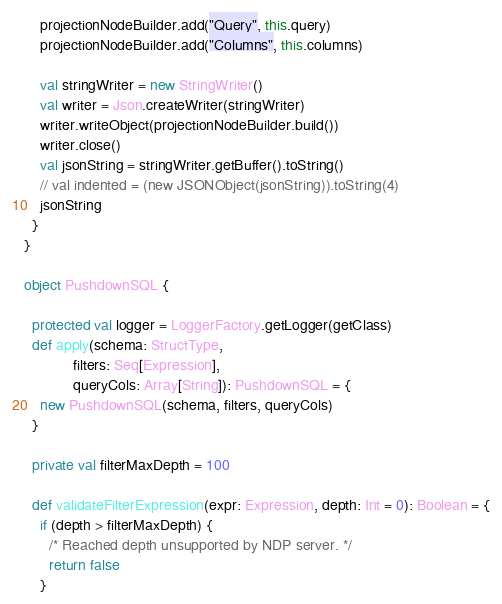<code> <loc_0><loc_0><loc_500><loc_500><_Scala_>    projectionNodeBuilder.add("Query", this.query)
    projectionNodeBuilder.add("Columns", this.columns)

    val stringWriter = new StringWriter()
    val writer = Json.createWriter(stringWriter)
    writer.writeObject(projectionNodeBuilder.build())
    writer.close()
    val jsonString = stringWriter.getBuffer().toString()
    // val indented = (new JSONObject(jsonString)).toString(4)
    jsonString
  }
}

object PushdownSQL {

  protected val logger = LoggerFactory.getLogger(getClass)
  def apply(schema: StructType,
            filters: Seq[Expression],
            queryCols: Array[String]): PushdownSQL = {
    new PushdownSQL(schema, filters, queryCols)
  }

  private val filterMaxDepth = 100

  def validateFilterExpression(expr: Expression, depth: Int = 0): Boolean = {
    if (depth > filterMaxDepth) {
      /* Reached depth unsupported by NDP server. */
      return false
    }</code> 